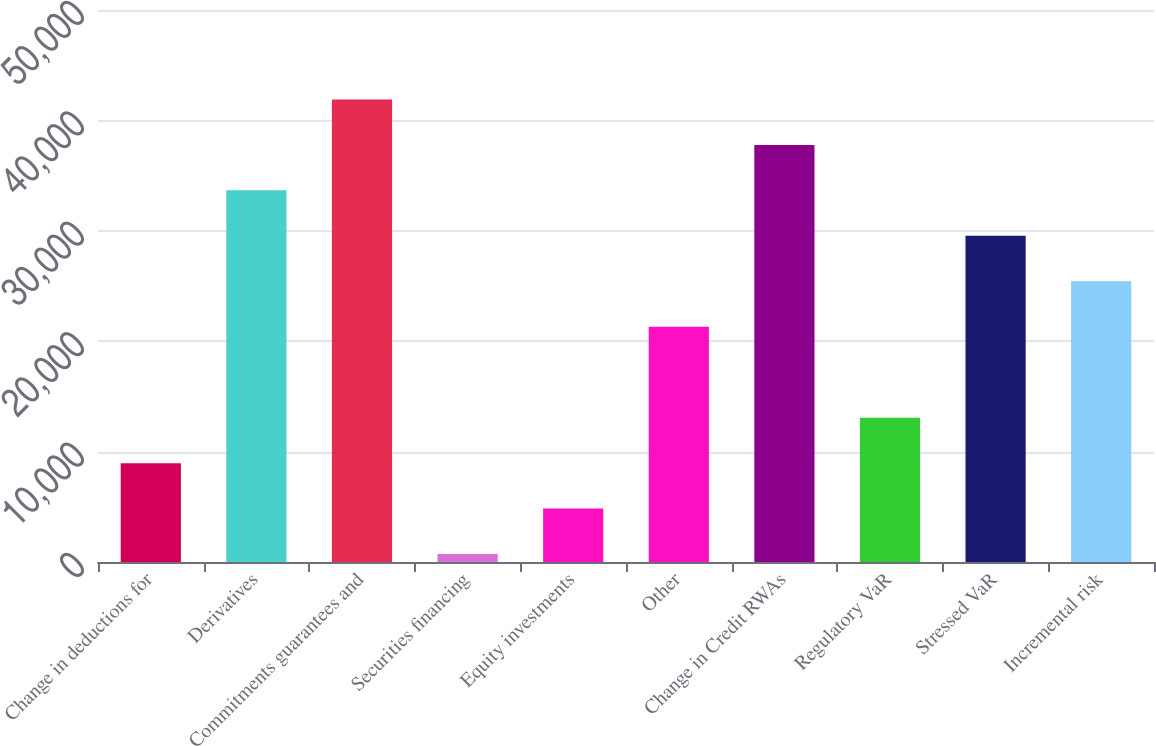<chart> <loc_0><loc_0><loc_500><loc_500><bar_chart><fcel>Change in deductions for<fcel>Derivatives<fcel>Commitments guarantees and<fcel>Securities financing<fcel>Equity investments<fcel>Other<fcel>Change in Credit RWAs<fcel>Regulatory VaR<fcel>Stressed VaR<fcel>Incremental risk<nl><fcel>8953.6<fcel>33663.4<fcel>41900<fcel>717<fcel>4835.3<fcel>21308.5<fcel>37781.7<fcel>13071.9<fcel>29545.1<fcel>25426.8<nl></chart> 